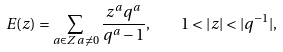<formula> <loc_0><loc_0><loc_500><loc_500>E ( z ) = \sum _ { a \in { Z } \, a \neq 0 } \frac { z ^ { a } q ^ { a } } { q ^ { a } - 1 } , \quad 1 < | z | < | q ^ { - 1 } | ,</formula> 